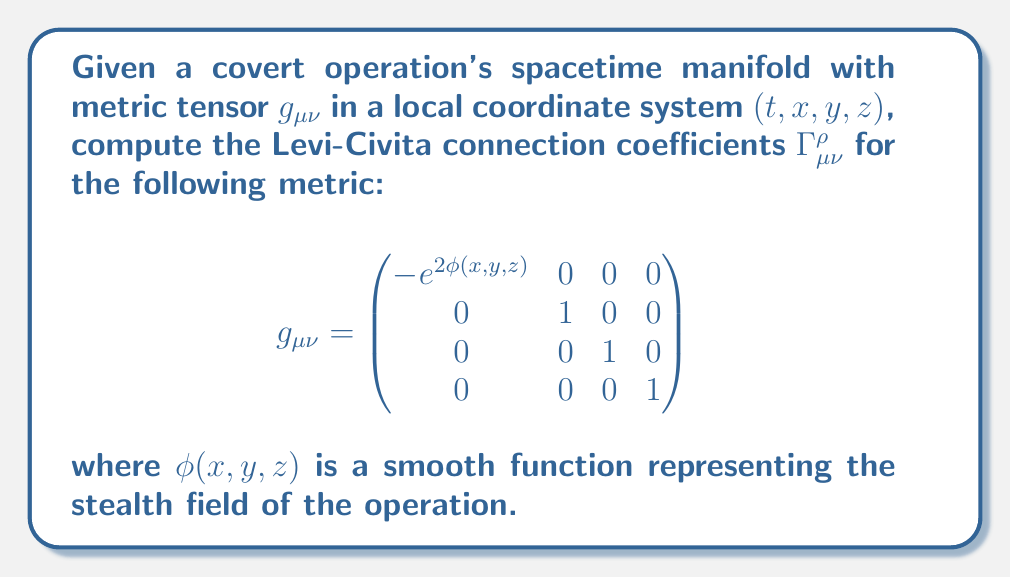Provide a solution to this math problem. To compute the Levi-Civita connection coefficients, we use the formula:

$$\Gamma^\rho_{\mu\nu} = \frac{1}{2}g^{\rho\sigma}(\partial_\mu g_{\nu\sigma} + \partial_\nu g_{\mu\sigma} - \partial_\sigma g_{\mu\nu})$$

Steps:
1) First, we need to find the inverse metric $g^{\mu\nu}$:
   $$g^{\mu\nu} = \begin{pmatrix}
   -e^{-2\phi(x,y,z)} & 0 & 0 & 0 \\
   0 & 1 & 0 & 0 \\
   0 & 0 & 1 & 0 \\
   0 & 0 & 0 & 1
   \end{pmatrix}$$

2) Now, we calculate the partial derivatives of the metric components:
   $\partial_x g_{00} = -2e^{2\phi}\frac{\partial\phi}{\partial x}$
   $\partial_y g_{00} = -2e^{2\phi}\frac{\partial\phi}{\partial y}$
   $\partial_z g_{00} = -2e^{2\phi}\frac{\partial\phi}{\partial z}$
   All other partial derivatives are zero.

3) Applying the formula for each combination of indices:

   For $\Gamma^0_{00}$:
   $$\Gamma^0_{00} = \frac{1}{2}g^{00}(\partial_0 g_{00} + \partial_0 g_{00} - \partial_0 g_{00}) = 0$$

   For $\Gamma^0_{0i}$ and $\Gamma^0_{i0}$ (where $i=1,2,3$):
   $$\Gamma^0_{0i} = \Gamma^0_{i0} = \frac{1}{2}g^{00}(\partial_i g_{00}) = e^{-2\phi}(-e^{2\phi}\frac{\partial\phi}{\partial x_i}) = -\frac{\partial\phi}{\partial x_i}$$

   For $\Gamma^i_{00}$ (where $i=1,2,3$):
   $$\Gamma^i_{00} = \frac{1}{2}g^{ii}(-\partial_i g_{00}) = \frac{1}{2}(2e^{2\phi}\frac{\partial\phi}{\partial x_i}) = e^{2\phi}\frac{\partial\phi}{\partial x_i}$$

4) All other connection coefficients are zero.
Answer: $\Gamma^0_{0i} = \Gamma^0_{i0} = -\frac{\partial\phi}{\partial x_i}$, $\Gamma^i_{00} = e^{2\phi}\frac{\partial\phi}{\partial x_i}$ for $i=1,2,3$; all others zero. 